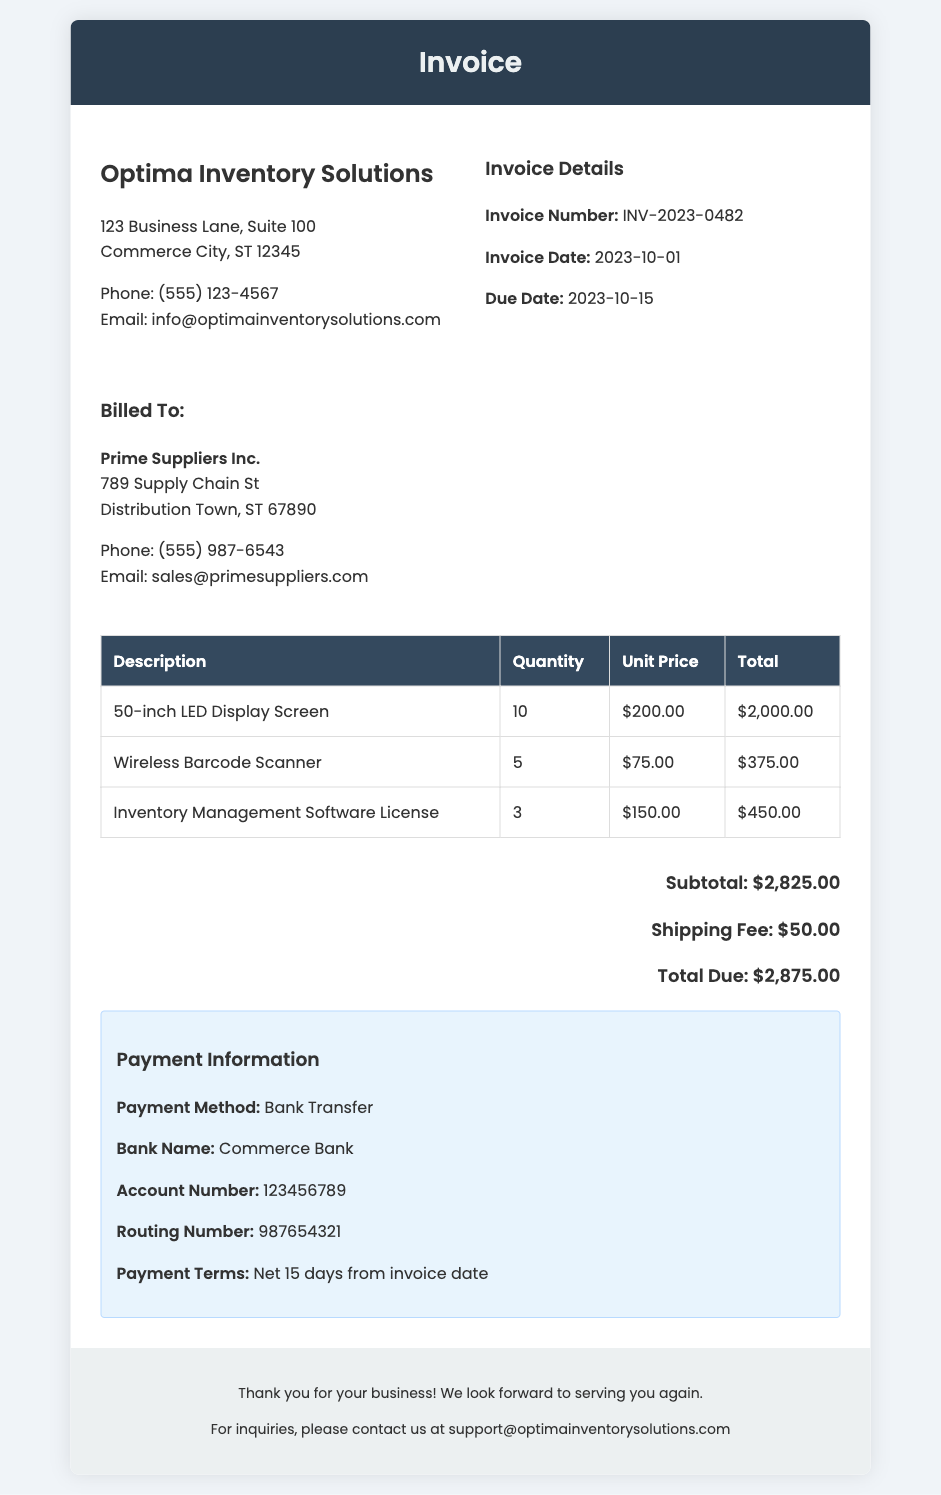What is the invoice number? The invoice number is the unique identifier for this transaction, listed in the document.
Answer: INV-2023-0482 What is the total due amount? The total due amount is the final amount that needs to be paid, calculated as subtotal plus shipping fee.
Answer: $2,875.00 What is the shipping fee? The shipping fee is the cost associated with delivering the items listed on the invoice.
Answer: $50.00 What is the payment method? The payment method specifies how the payment should be made for the invoice.
Answer: Bank Transfer When is the due date for payment? The due date indicates when payment must be received to avoid penalties.
Answer: 2023-10-15 How many Wireless Barcode Scanners were purchased? This question looks for the quantity of a specific item included in the invoice.
Answer: 5 What is the subtotal amount before shipping? The subtotal is the total cost of all items before adding any shipping fees.
Answer: $2,825.00 Who is billed for this invoice? This question asks for the name of the company that is responsible for paying the invoice.
Answer: Prime Suppliers Inc What is the account number for the bank transfer? This information is needed to identify the specific bank account for the transaction.
Answer: 123456789 